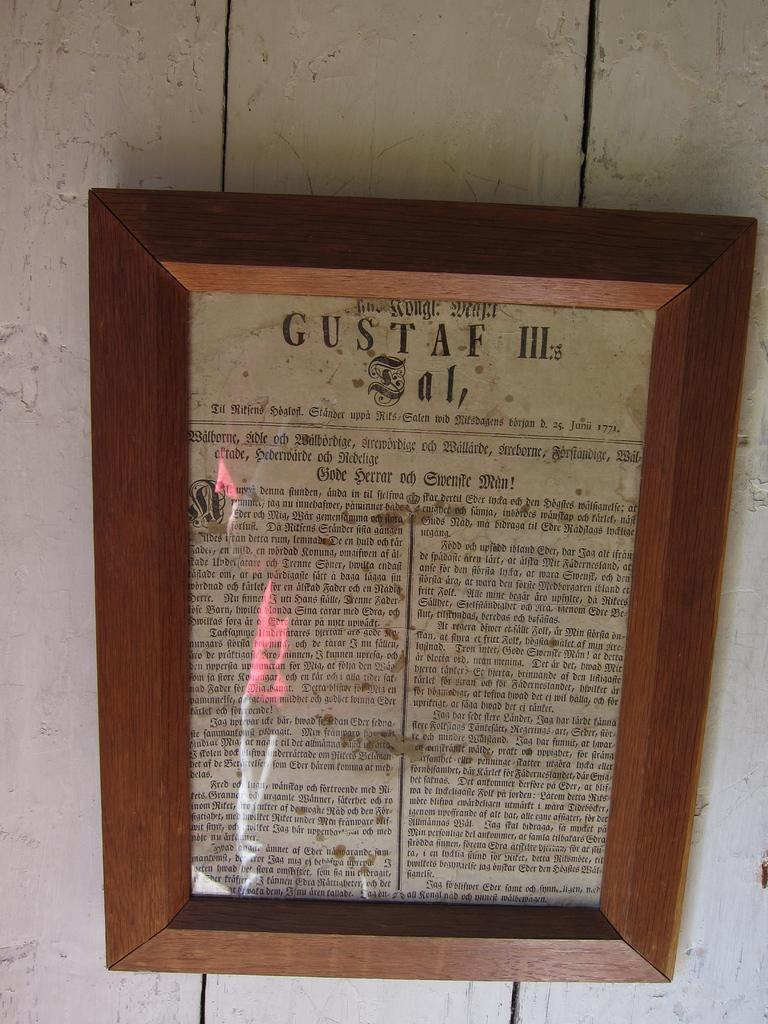<image>
Share a concise interpretation of the image provided. A wooden framed scripture named GUSTAF III:s Ial. 